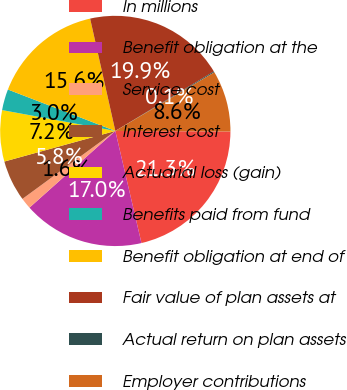Convert chart. <chart><loc_0><loc_0><loc_500><loc_500><pie_chart><fcel>In millions<fcel>Benefit obligation at the<fcel>Service cost<fcel>Interest cost<fcel>Actuarial loss (gain)<fcel>Benefits paid from fund<fcel>Benefit obligation at end of<fcel>Fair value of plan assets at<fcel>Actual return on plan assets<fcel>Employer contributions<nl><fcel>21.27%<fcel>17.04%<fcel>1.55%<fcel>5.77%<fcel>7.18%<fcel>2.96%<fcel>15.63%<fcel>19.86%<fcel>0.14%<fcel>8.59%<nl></chart> 